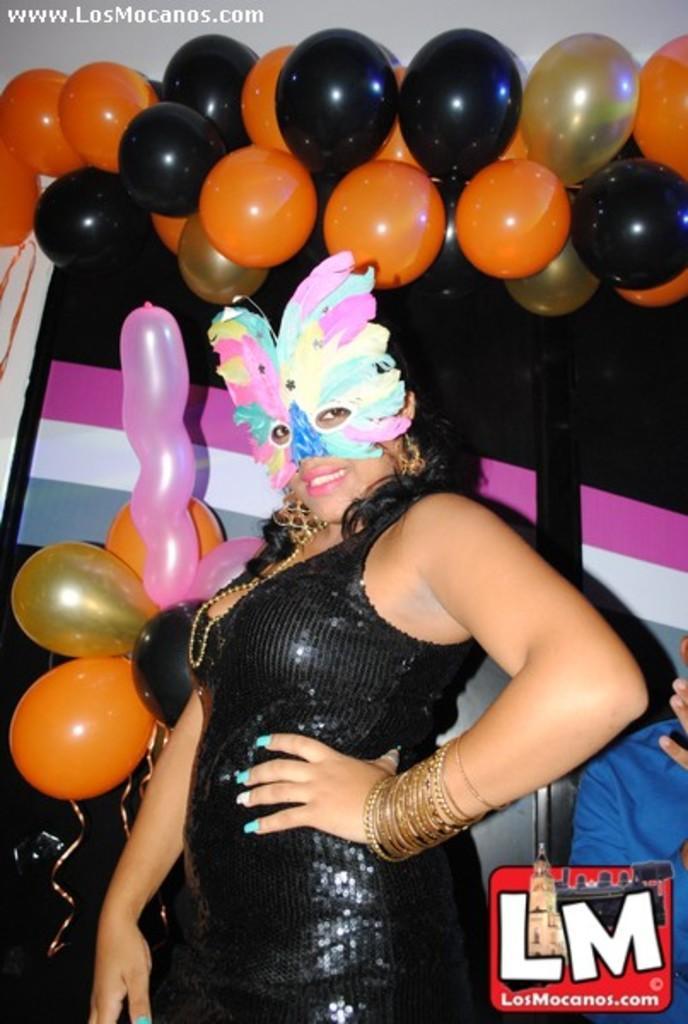Please provide a concise description of this image. In this image I can see a woman standing and wearing a face mask and giving pose for the picture. At the top of the image I can see some balloons and in the right bottom corner I can see some text 